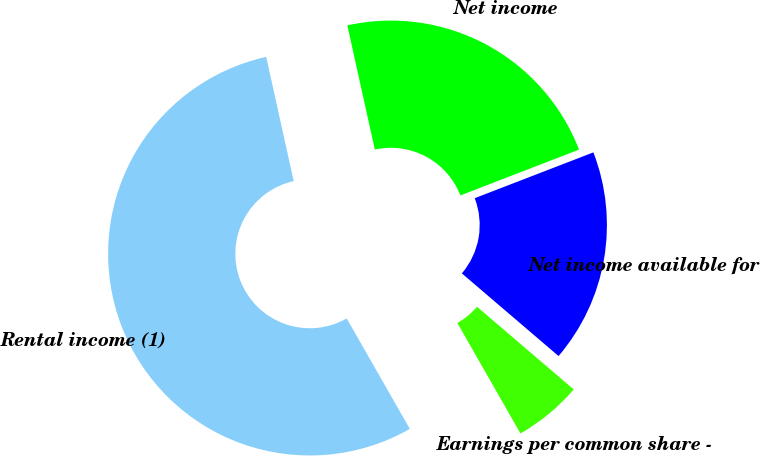Convert chart to OTSL. <chart><loc_0><loc_0><loc_500><loc_500><pie_chart><fcel>Rental income (1)<fcel>Net income<fcel>Net income available for<fcel>Earnings per common share -<nl><fcel>54.79%<fcel>22.6%<fcel>17.12%<fcel>5.48%<nl></chart> 